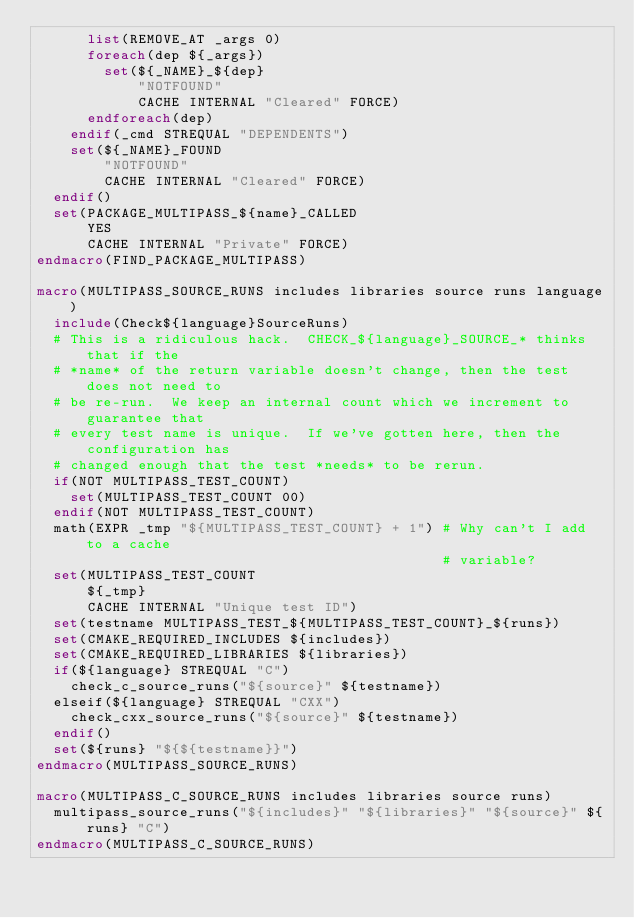Convert code to text. <code><loc_0><loc_0><loc_500><loc_500><_CMake_>      list(REMOVE_AT _args 0)
      foreach(dep ${_args})
        set(${_NAME}_${dep}
            "NOTFOUND"
            CACHE INTERNAL "Cleared" FORCE)
      endforeach(dep)
    endif(_cmd STREQUAL "DEPENDENTS")
    set(${_NAME}_FOUND
        "NOTFOUND"
        CACHE INTERNAL "Cleared" FORCE)
  endif()
  set(PACKAGE_MULTIPASS_${name}_CALLED
      YES
      CACHE INTERNAL "Private" FORCE)
endmacro(FIND_PACKAGE_MULTIPASS)

macro(MULTIPASS_SOURCE_RUNS includes libraries source runs language)
  include(Check${language}SourceRuns)
  # This is a ridiculous hack.  CHECK_${language}_SOURCE_* thinks that if the
  # *name* of the return variable doesn't change, then the test does not need to
  # be re-run.  We keep an internal count which we increment to guarantee that
  # every test name is unique.  If we've gotten here, then the configuration has
  # changed enough that the test *needs* to be rerun.
  if(NOT MULTIPASS_TEST_COUNT)
    set(MULTIPASS_TEST_COUNT 00)
  endif(NOT MULTIPASS_TEST_COUNT)
  math(EXPR _tmp "${MULTIPASS_TEST_COUNT} + 1") # Why can't I add to a cache
                                                # variable?
  set(MULTIPASS_TEST_COUNT
      ${_tmp}
      CACHE INTERNAL "Unique test ID")
  set(testname MULTIPASS_TEST_${MULTIPASS_TEST_COUNT}_${runs})
  set(CMAKE_REQUIRED_INCLUDES ${includes})
  set(CMAKE_REQUIRED_LIBRARIES ${libraries})
  if(${language} STREQUAL "C")
    check_c_source_runs("${source}" ${testname})
  elseif(${language} STREQUAL "CXX")
    check_cxx_source_runs("${source}" ${testname})
  endif()
  set(${runs} "${${testname}}")
endmacro(MULTIPASS_SOURCE_RUNS)

macro(MULTIPASS_C_SOURCE_RUNS includes libraries source runs)
  multipass_source_runs("${includes}" "${libraries}" "${source}" ${runs} "C")
endmacro(MULTIPASS_C_SOURCE_RUNS)
</code> 